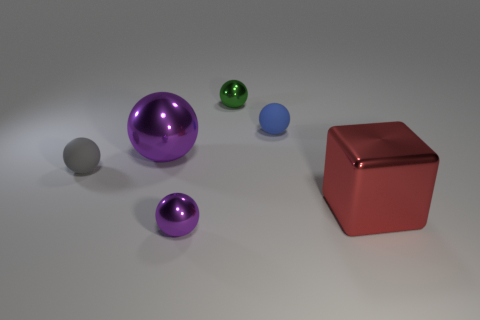Subtract all blue spheres. How many spheres are left? 4 Subtract 1 balls. How many balls are left? 4 Subtract all blue balls. How many balls are left? 4 Subtract all purple balls. Subtract all purple blocks. How many balls are left? 3 Add 1 brown shiny spheres. How many objects exist? 7 Subtract all balls. How many objects are left? 1 Subtract 0 yellow balls. How many objects are left? 6 Subtract all large red blocks. Subtract all metallic balls. How many objects are left? 2 Add 6 small gray matte spheres. How many small gray matte spheres are left? 7 Add 4 big red things. How many big red things exist? 5 